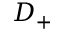Convert formula to latex. <formula><loc_0><loc_0><loc_500><loc_500>D _ { + }</formula> 